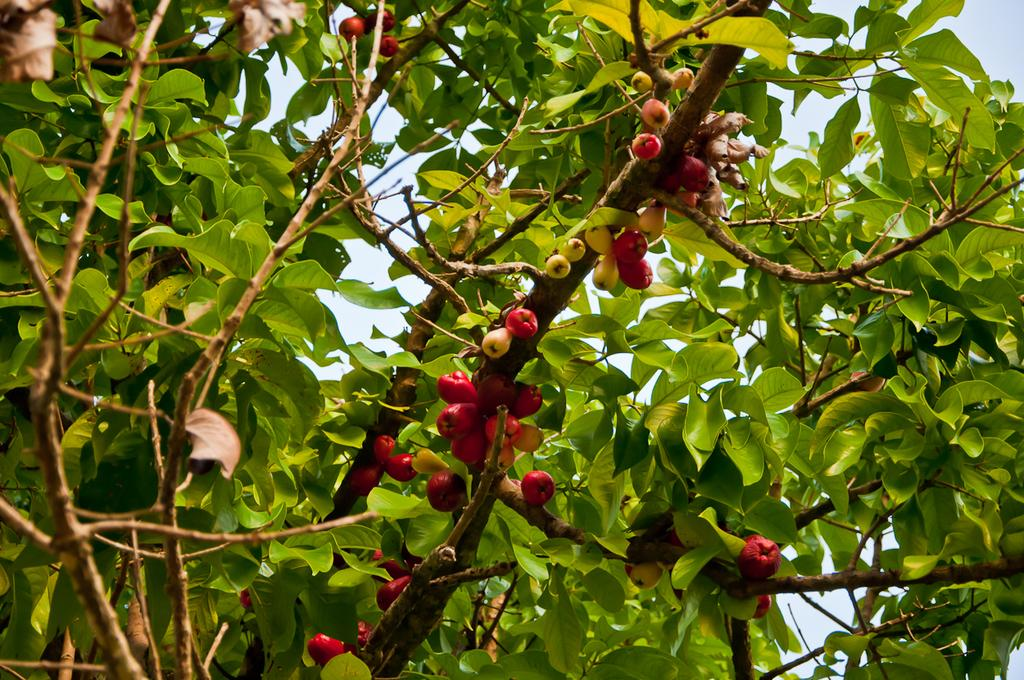What type of plant can be seen in the image? There is a tree with fruits in the image. What can be seen in the background of the image? The sky is visible in the background of the image. What type of board is being used for learning in the image? There is no board or learning activity present in the image; it features a tree with fruits and a visible sky in the background. 